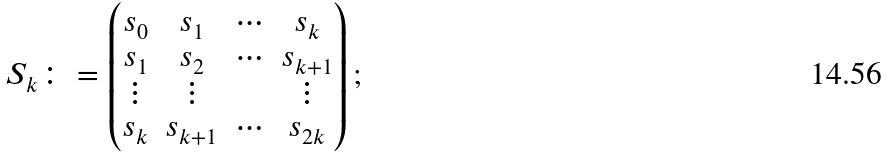Convert formula to latex. <formula><loc_0><loc_0><loc_500><loc_500>S _ { k } \colon = \begin{pmatrix} s _ { 0 } & s _ { 1 } & \cdots & s _ { k } \\ s _ { 1 } & s _ { 2 } & \cdots & s _ { k + 1 } \\ \vdots & \vdots & & \vdots \\ s _ { k } & s _ { k + 1 } & \cdots & s _ { 2 k } \end{pmatrix} ;</formula> 